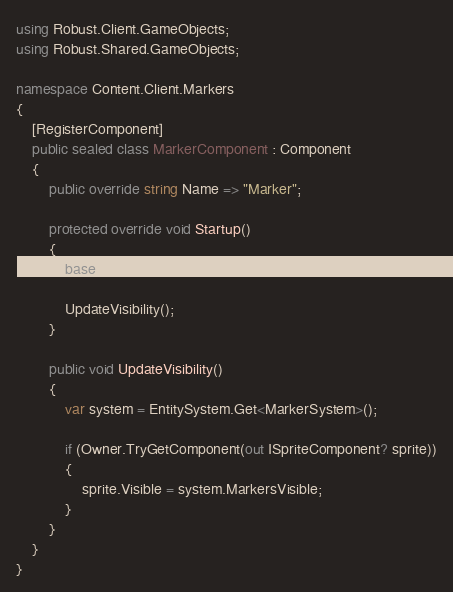Convert code to text. <code><loc_0><loc_0><loc_500><loc_500><_C#_>using Robust.Client.GameObjects;
using Robust.Shared.GameObjects;

namespace Content.Client.Markers
{
    [RegisterComponent]
    public sealed class MarkerComponent : Component
    {
        public override string Name => "Marker";

        protected override void Startup()
        {
            base.Startup();

            UpdateVisibility();
        }

        public void UpdateVisibility()
        {
            var system = EntitySystem.Get<MarkerSystem>();

            if (Owner.TryGetComponent(out ISpriteComponent? sprite))
            {
                sprite.Visible = system.MarkersVisible;
            }
        }
    }
}
</code> 